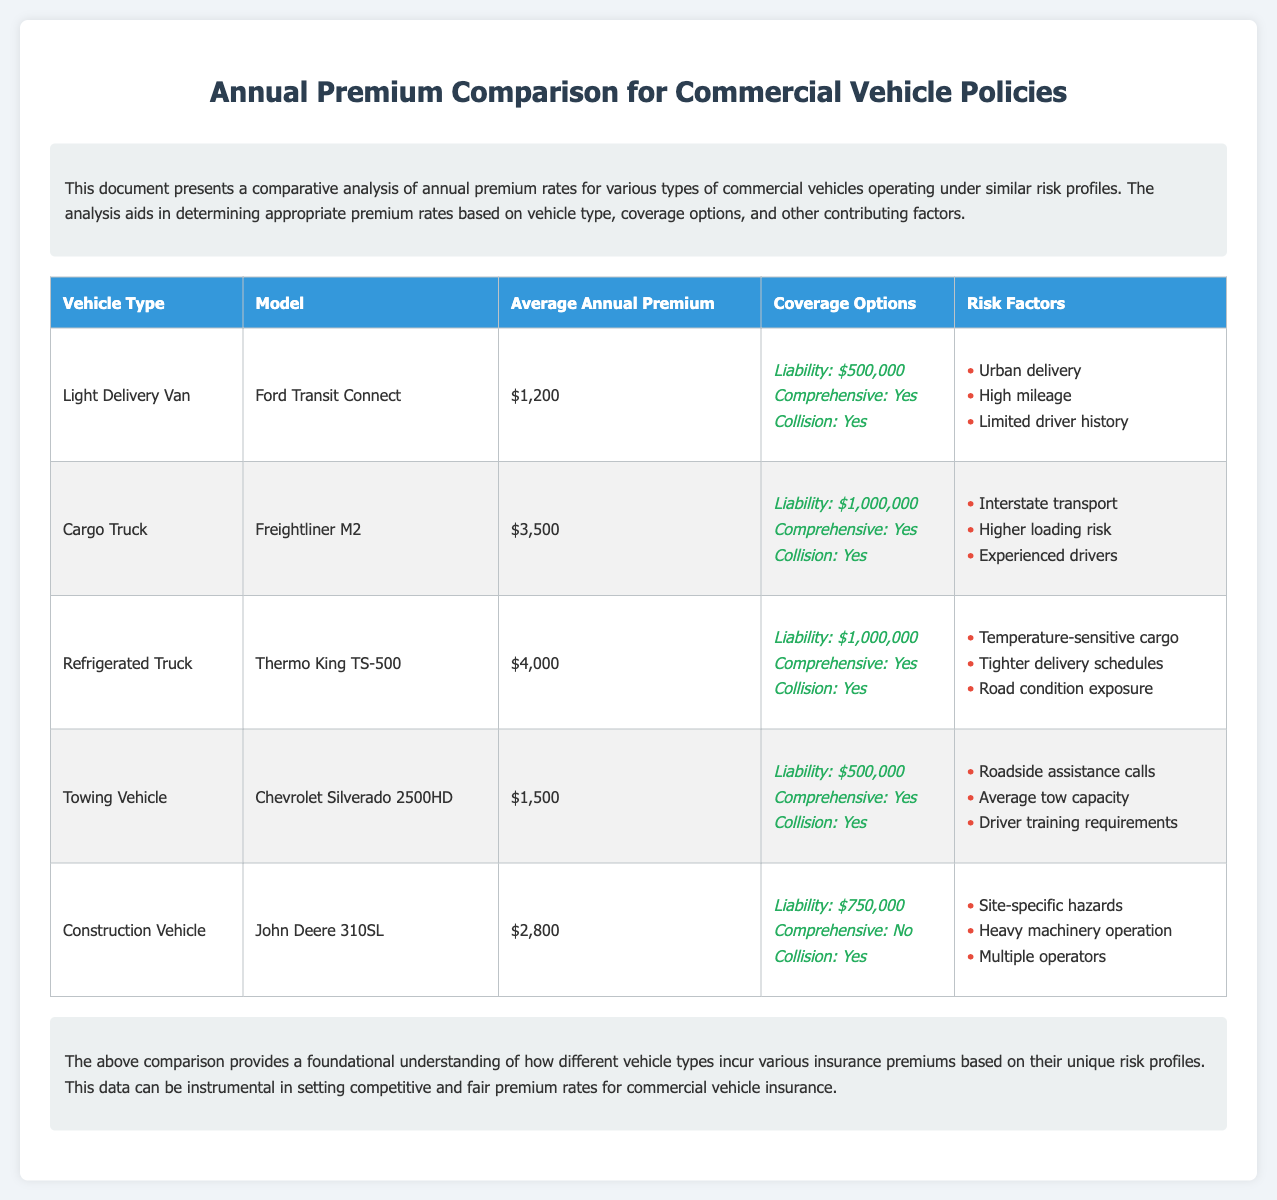What is the average annual premium for a Light Delivery Van? The average annual premium for a Light Delivery Van, specifically the Ford Transit Connect, is detailed in the table.
Answer: $1,200 What liability coverage does the Cargo Truck have? The table specifies the liability coverage amount for the Cargo Truck, which is $1,000,000.
Answer: $1,000,000 Which vehicle type has the highest average annual premium? By comparing the values in the table, the vehicle type with the highest average annual premium is identified.
Answer: Refrigerated Truck How many risk factors are listed for the Towing Vehicle? The risk factors listed in the table for the Towing Vehicle can be counted to provide a total.
Answer: 3 What is the coverage option for the Construction Vehicle? The coverage option for the Construction Vehicle is mentioned in the table, indicating the liability amount and collision coverage.
Answer: Liability: $750,000 Which vehicle type involves temperature-sensitive cargo? The vehicle type associated with temperature-sensitive cargo is found in the risk factors for the Refrigerated Truck.
Answer: Refrigerated Truck What maximum liability coverage is noted for the Light Delivery Van? The liability coverage for the Light Delivery Van is stated in the coverage options presented in the table.
Answer: $500,000 What is the purpose of this document? The introduction explains the primary goal of the document, which is to provide a comparative analysis of premium rates.
Answer: Comparative analysis What is the average annual premium for a Cargo Truck? The document lists the average annual premium for a Cargo Truck, enabling easy information retrieval.
Answer: $3,500 